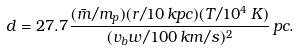<formula> <loc_0><loc_0><loc_500><loc_500>d = 2 7 . 7 \frac { ( \bar { m } / m _ { p } ) ( r / 1 0 \, k p c ) ( T / 1 0 ^ { 4 } \, K ) } { ( v _ { b } w / 1 0 0 \, k m / s ) ^ { 2 } } \, p c .</formula> 